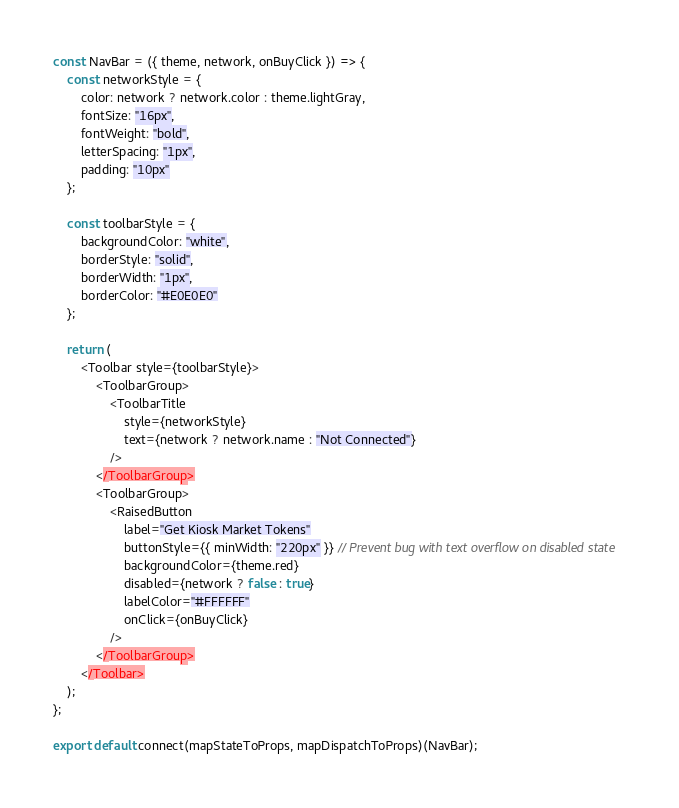<code> <loc_0><loc_0><loc_500><loc_500><_JavaScript_>const NavBar = ({ theme, network, onBuyClick }) => {
	const networkStyle = {
		color: network ? network.color : theme.lightGray,
		fontSize: "16px",
		fontWeight: "bold",
		letterSpacing: "1px",
		padding: "10px"
	};

	const toolbarStyle = {
		backgroundColor: "white",
		borderStyle: "solid",
		borderWidth: "1px",
		borderColor: "#E0E0E0"
	};

	return (
		<Toolbar style={toolbarStyle}>
			<ToolbarGroup>
				<ToolbarTitle
					style={networkStyle}
					text={network ? network.name : "Not Connected"}
				/>
			</ToolbarGroup>
			<ToolbarGroup>
				<RaisedButton
					label="Get Kiosk Market Tokens"
					buttonStyle={{ minWidth: "220px" }} // Prevent bug with text overflow on disabled state
					backgroundColor={theme.red}
					disabled={network ? false : true}
					labelColor="#FFFFFF"
					onClick={onBuyClick}
				/>
			</ToolbarGroup>
		</Toolbar>
	);
};

export default connect(mapStateToProps, mapDispatchToProps)(NavBar);</code> 